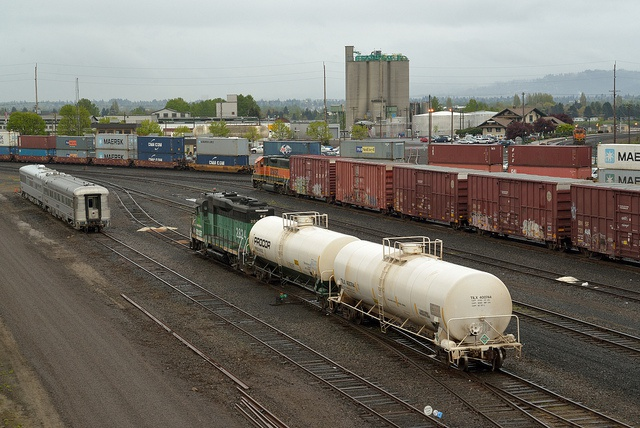Describe the objects in this image and their specific colors. I can see train in lightgray, ivory, black, darkgray, and gray tones, train in lightgray, maroon, black, gray, and brown tones, train in lightgray, gray, maroon, darkgray, and blue tones, train in lightgray, gray, darkgray, and black tones, and car in lightgray, darkgray, gray, and black tones in this image. 